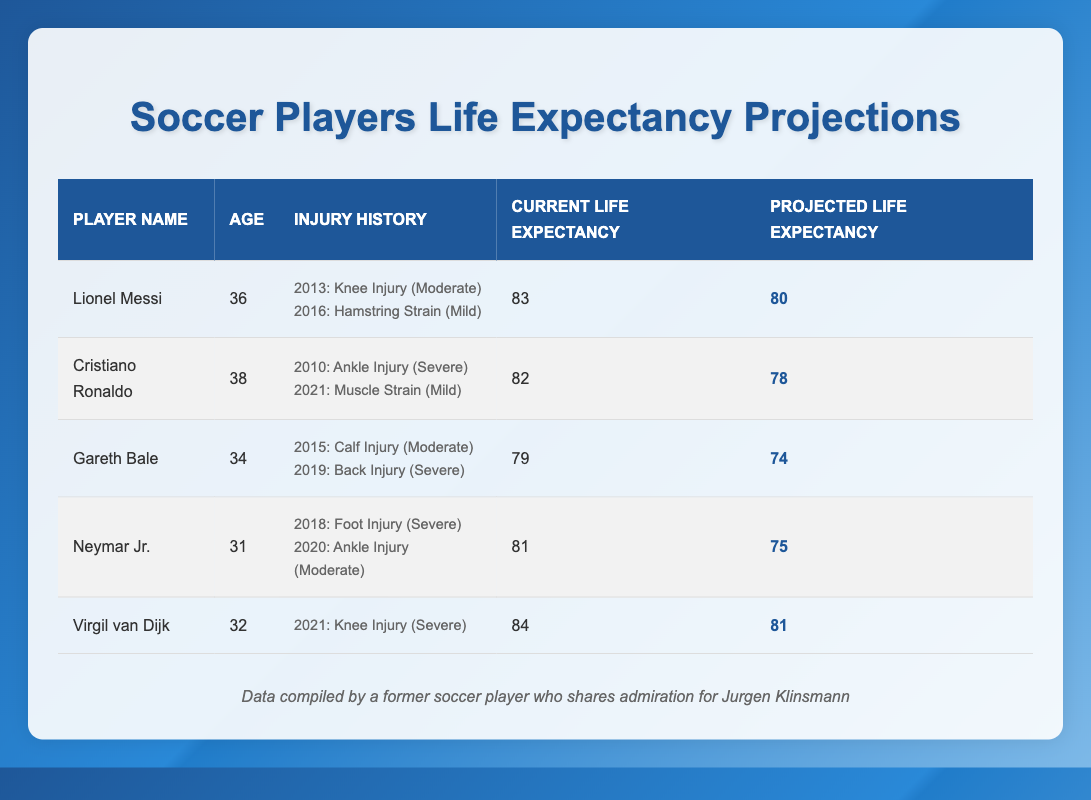What is the projected life expectancy of Lionel Messi? In the table, Lionel Messi's projected life expectancy is explicitly listed as 80.
Answer: 80 Which player has the highest current life expectancy? Based on the table, Virgil van Dijk has a current life expectancy of 84, which is the highest when compared to others.
Answer: 84 What is the average projected life expectancy of the players listed in the table? To find the average projected life expectancy, add all projected values: (80 + 78 + 74 + 75 + 81) = 388. There are 5 players, so the average is 388/5 = 77.6.
Answer: 77.6 Did Cristiano Ronaldo have a severe injury? Referring to the injury history in the table, Cristiano Ronaldo did indeed have a severe injury (Ankle Injury in 2010).
Answer: Yes What is the total impact on life expectancy due to injuries for Gareth Bale? Gareth Bale has two injuries. The knee injury in 2015 has an impact of -2, and the back injury in 2019 has an impact of -3. The total impact is calculated by summing these values: -2 + -3 = -5.
Answer: -5 What is the difference in current life expectancy between Neymar Jr. and Gareth Bale? Neymar Jr.'s current life expectancy is 81, while Gareth Bale's is 79. The difference is calculated as 81 - 79 = 2.
Answer: 2 Which player has had a muscle strain injury? By checking the injury histories, Cristiano Ronaldo had a muscle strain in 2021.
Answer: Cristiano Ronaldo What is the injury severity of Neymar Jr.'s foot injury? According to the table, Neymar Jr.'s foot injury in 2018 is classified as severe.
Answer: Severe Which player has the longest age currently and what is their projected life expectancy? Among the players listed, Cristiano Ronaldo is currently 38 years old, and his projected life expectancy is 78.
Answer: 78 